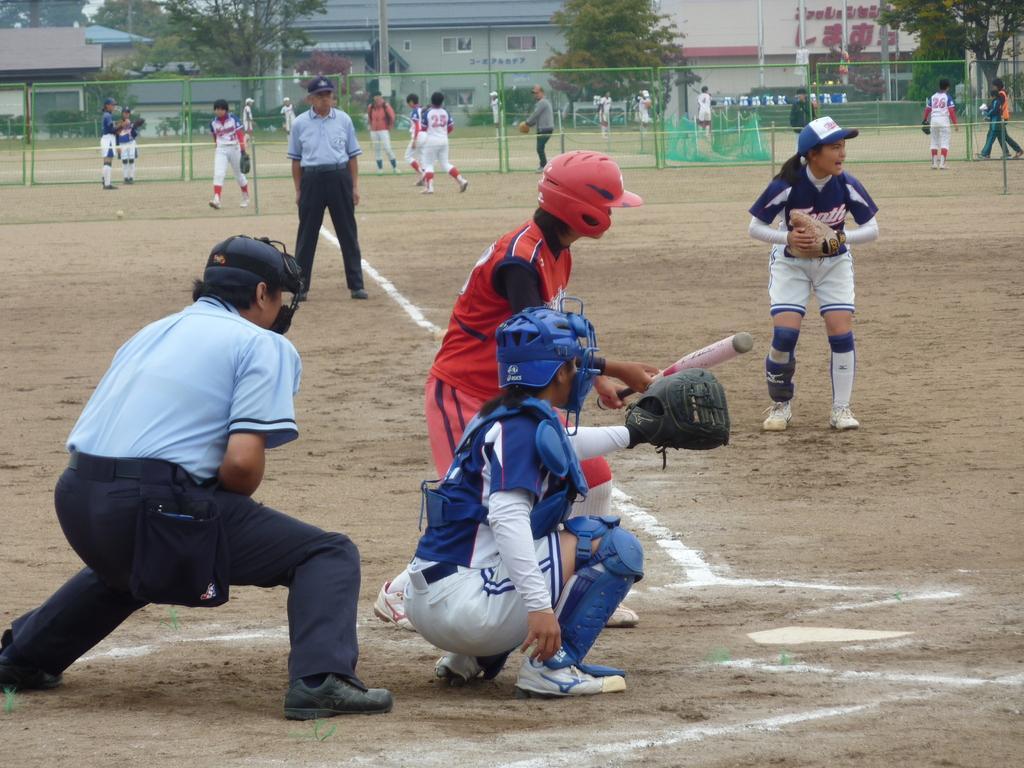Describe this image in one or two sentences. In this image, we can see people on the ground. In the middle of the image, we can see a person holding a stick. In the background, we can see the people, mesh, buildings, walls, trees, plants and some objects. 